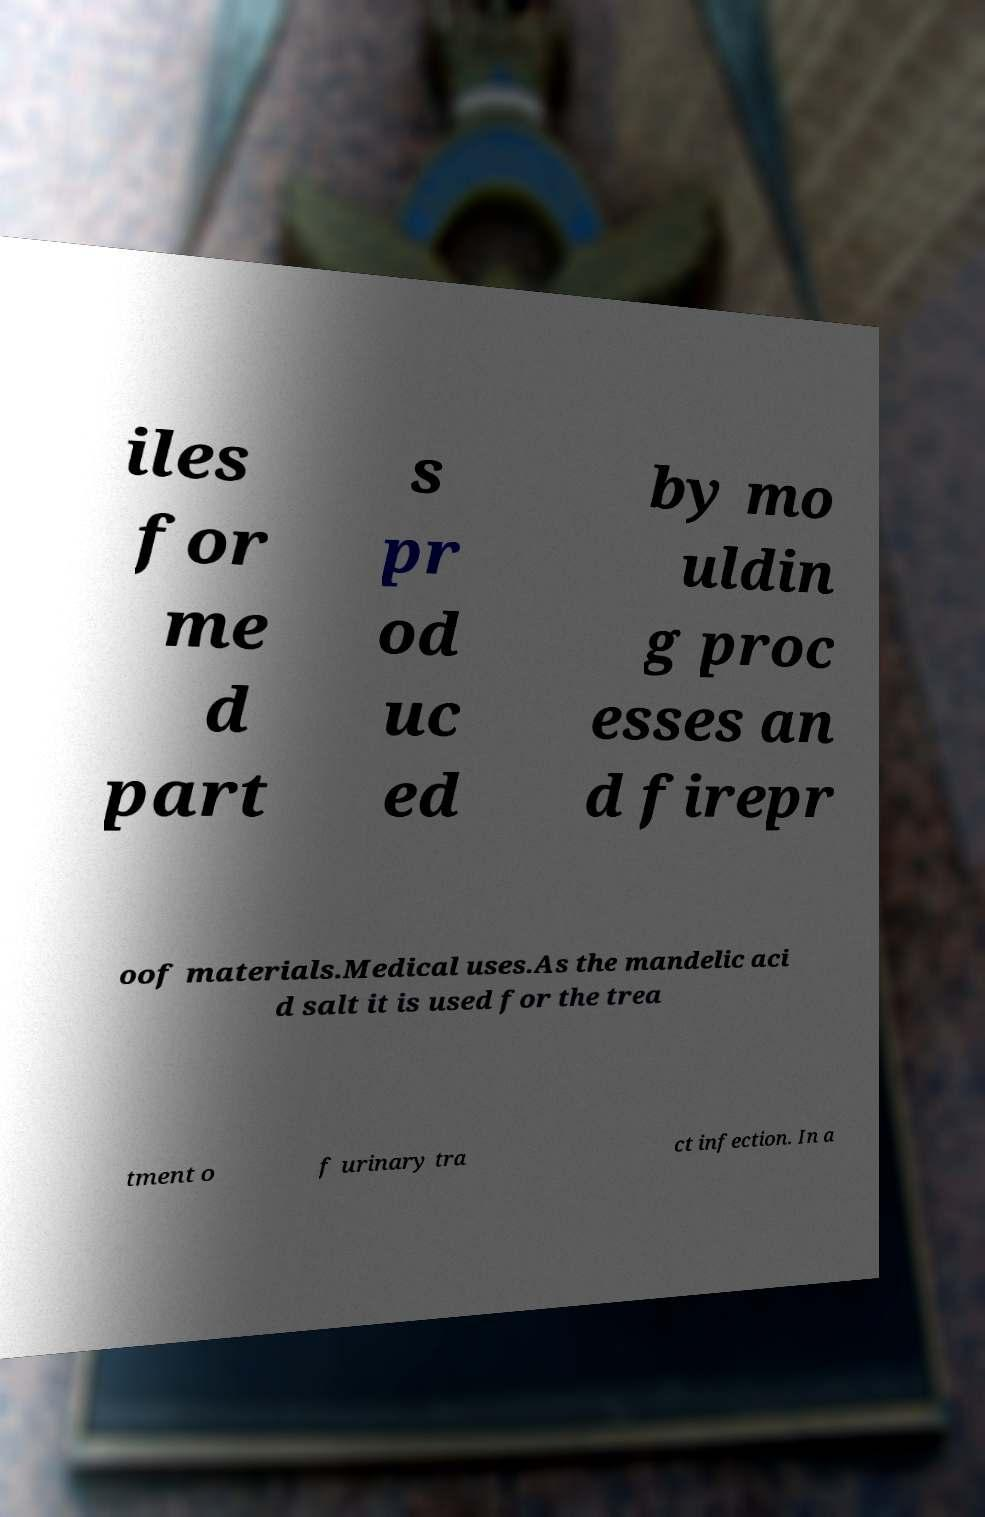There's text embedded in this image that I need extracted. Can you transcribe it verbatim? iles for me d part s pr od uc ed by mo uldin g proc esses an d firepr oof materials.Medical uses.As the mandelic aci d salt it is used for the trea tment o f urinary tra ct infection. In a 